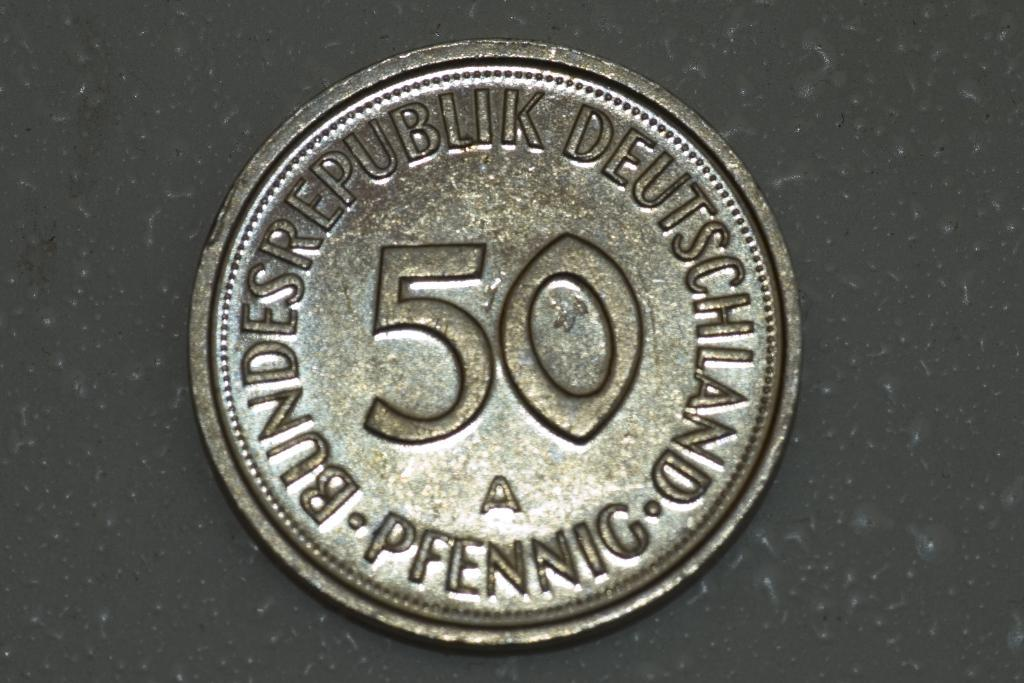What object is the main subject of the image? There is a coin in the image. What is the color of the surface on which the coin is placed? The coin is on a black surface. What type of magic is being performed with the coin in the image? There is no indication of magic or any magical activity in the image; it simply shows a coin on a black surface. 